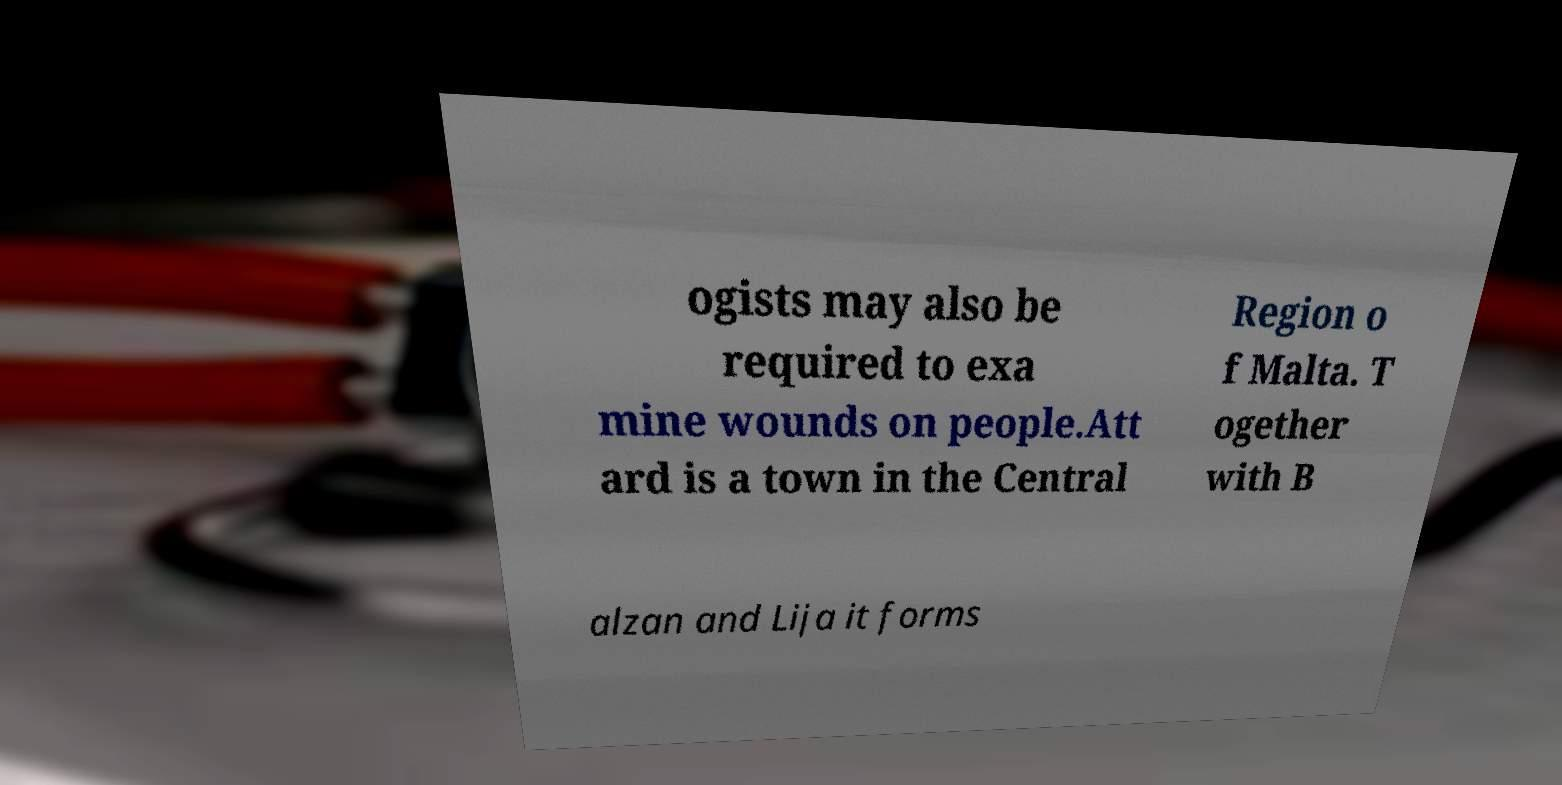Can you read and provide the text displayed in the image?This photo seems to have some interesting text. Can you extract and type it out for me? ogists may also be required to exa mine wounds on people.Att ard is a town in the Central Region o f Malta. T ogether with B alzan and Lija it forms 